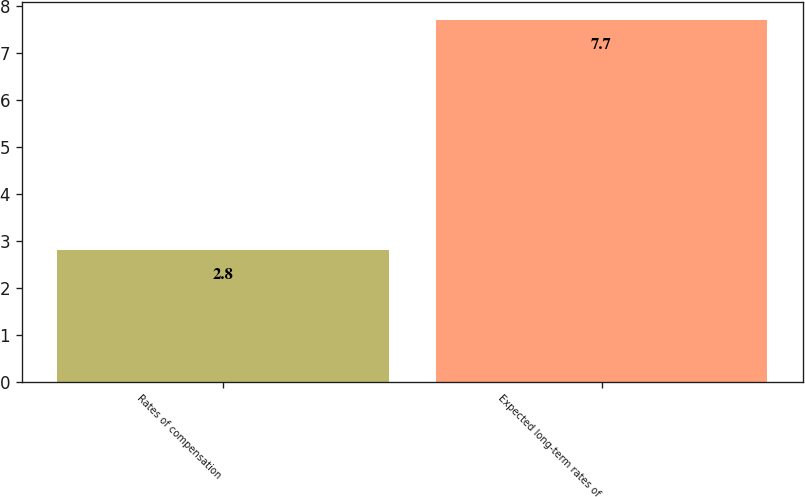Convert chart. <chart><loc_0><loc_0><loc_500><loc_500><bar_chart><fcel>Rates of compensation<fcel>Expected long-term rates of<nl><fcel>2.8<fcel>7.7<nl></chart> 